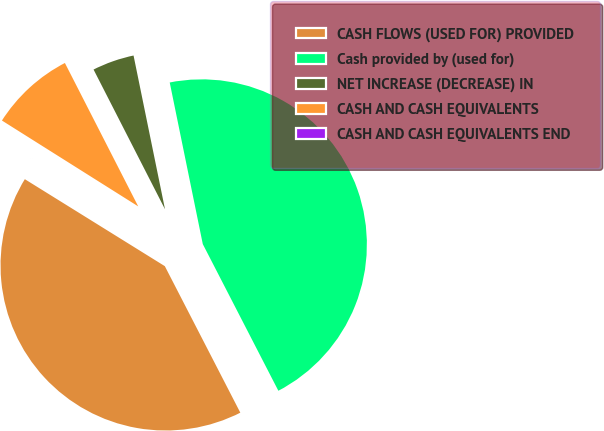Convert chart to OTSL. <chart><loc_0><loc_0><loc_500><loc_500><pie_chart><fcel>CASH FLOWS (USED FOR) PROVIDED<fcel>Cash provided by (used for)<fcel>NET INCREASE (DECREASE) IN<fcel>CASH AND CASH EQUIVALENTS<fcel>CASH AND CASH EQUIVALENTS END<nl><fcel>41.42%<fcel>45.64%<fcel>4.31%<fcel>8.53%<fcel>0.1%<nl></chart> 